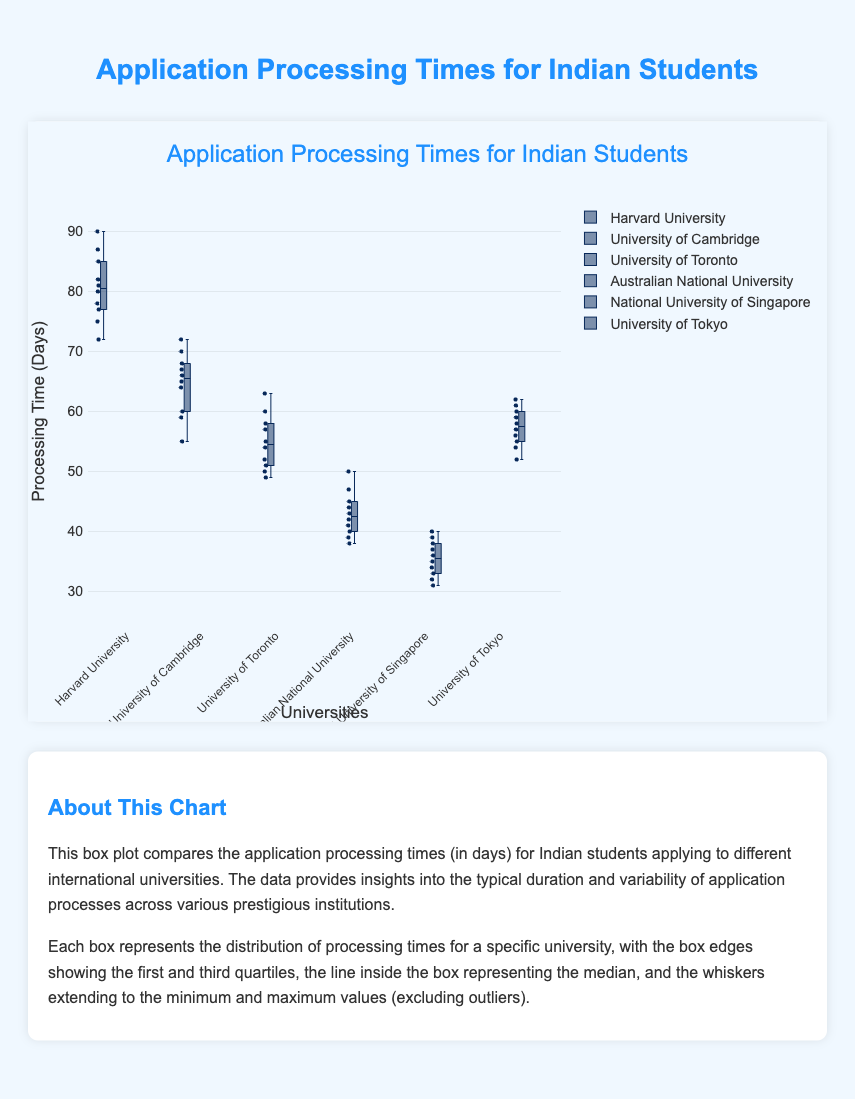What is the title of the figure? The title can usually be found at the top of the figure. It summarizes the main content of the plot. Here, the title is specifically designed to provide context about the application processing times for Indian students.
Answer: "Application Processing Times for Indian Students" What is the median application processing time for Harvard University? To find the median, locate the line inside the box for Harvard University. The median is the value where half the data is below and half is above.
Answer: 80 days Which university has the shortest minimum application processing time? The minimum value can be identified by looking at the lowest point of the whiskers for each university. The university with the lowest point has the shortest minimum time.
Answer: National University of Singapore Compare the median application processing times between University of Cambridge and University of Toronto. Which university has a shorter median time? To compare medians, locate the lines inside the boxes for each university. The lower median value indicates a shorter median processing time.
Answer: University of Toronto What is the interquartile range (IQR) for Australian National University? The IQR is the difference between the third quartile (top edge of the box) and the first quartile (bottom edge of the box). Identify these points for Australian National University and subtract the first quartile from the third quartile.
Answer: 8 days (47 - 39) Which university has the greatest variability in application processing times? Variability can be assessed by the range of the whiskers and the spread of the box. The greater the distance between the minimum and maximum values (whiskers), the higher the variability.
Answer: Harvard University What is the range of application processing times for National University of Singapore? The range is the difference between the maximum and minimum values of processing times. Identify the top and bottom whiskers for National University of Singapore and subtract the minimum from the maximum.
Answer: 9 days (40 - 31) How does the overall distribution of application times for University of Tokyo compare to that of Harvard University? Compare the spread of the boxes and whiskers, the median lines, and overall distribution shapes for both universities. Note which has a wider range, higher median, etc.
Answer: University of Tokyo has a narrower range and a lower median compared to Harvard University 